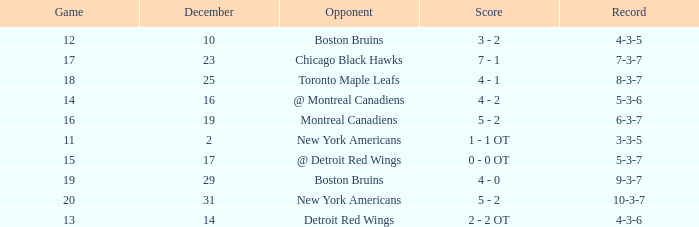Which Score has a December smaller than 14, and a Game of 12? 3 - 2. 